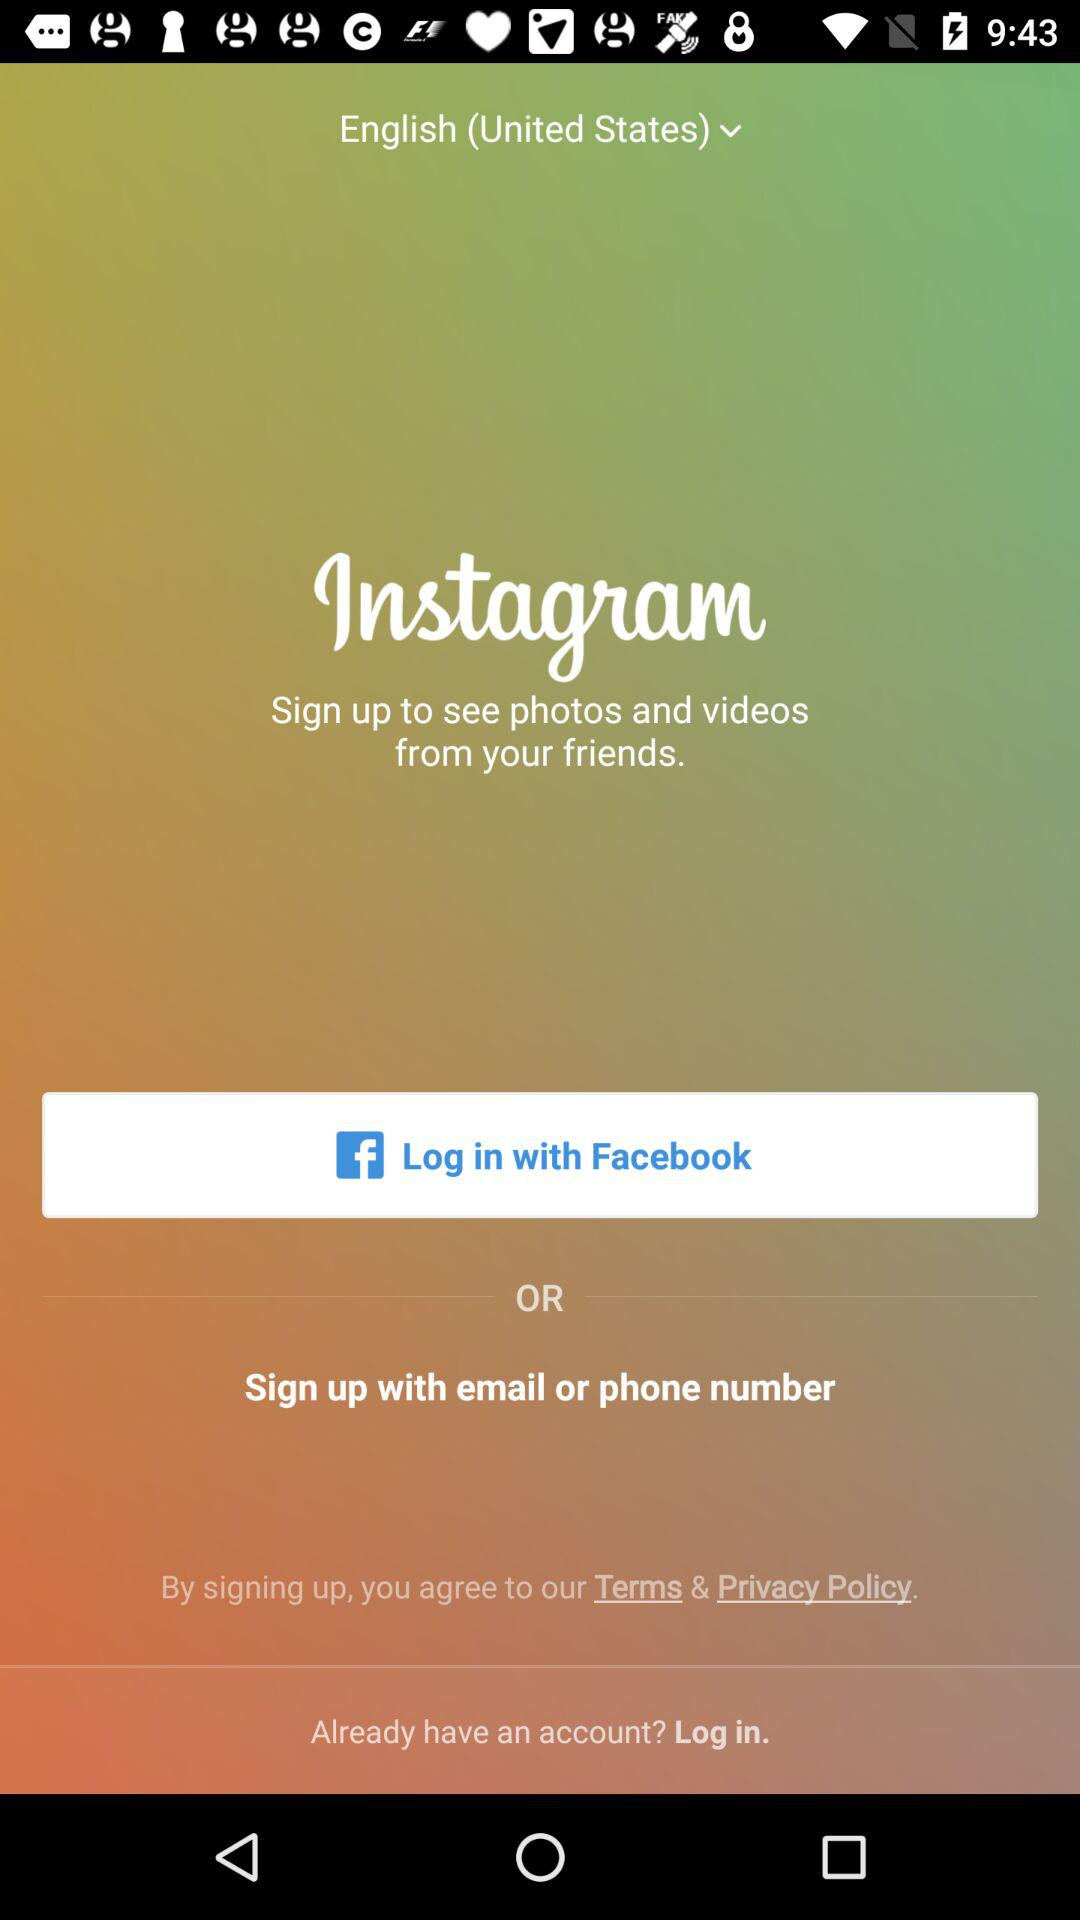What is the name of the application? The name of the application is "Instagram". 